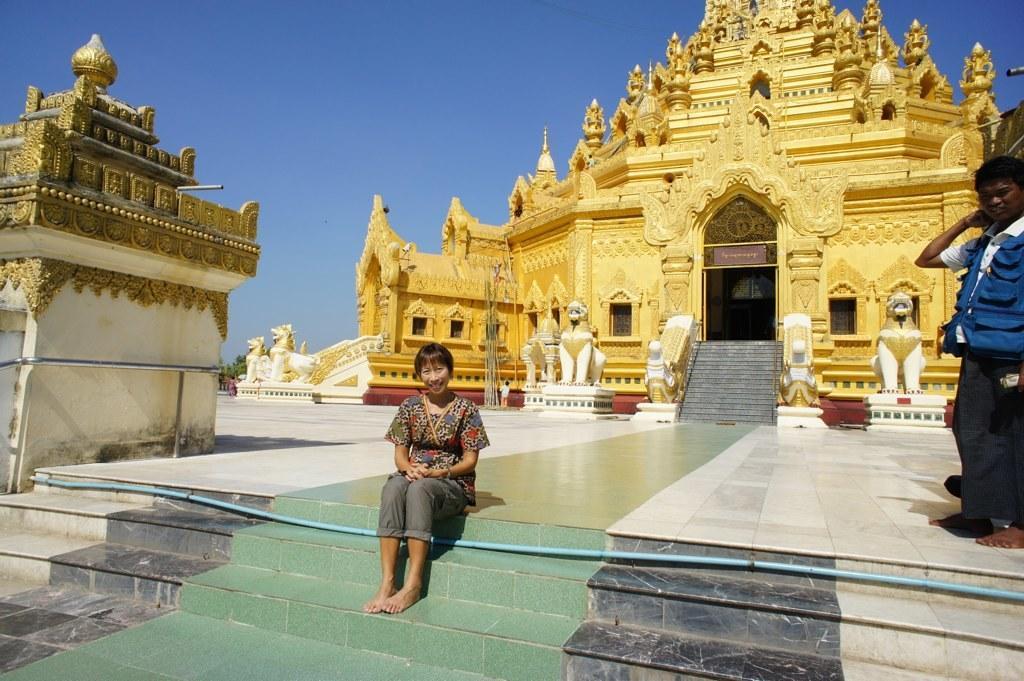Please provide a concise description of this image. In this image there are steps. On the steps a lady is sitting. Near to the steps there is a pipe. And a person is standing on the right side. And there is a building. Near to the building there are steps. There are statues. In the background there is sky. 